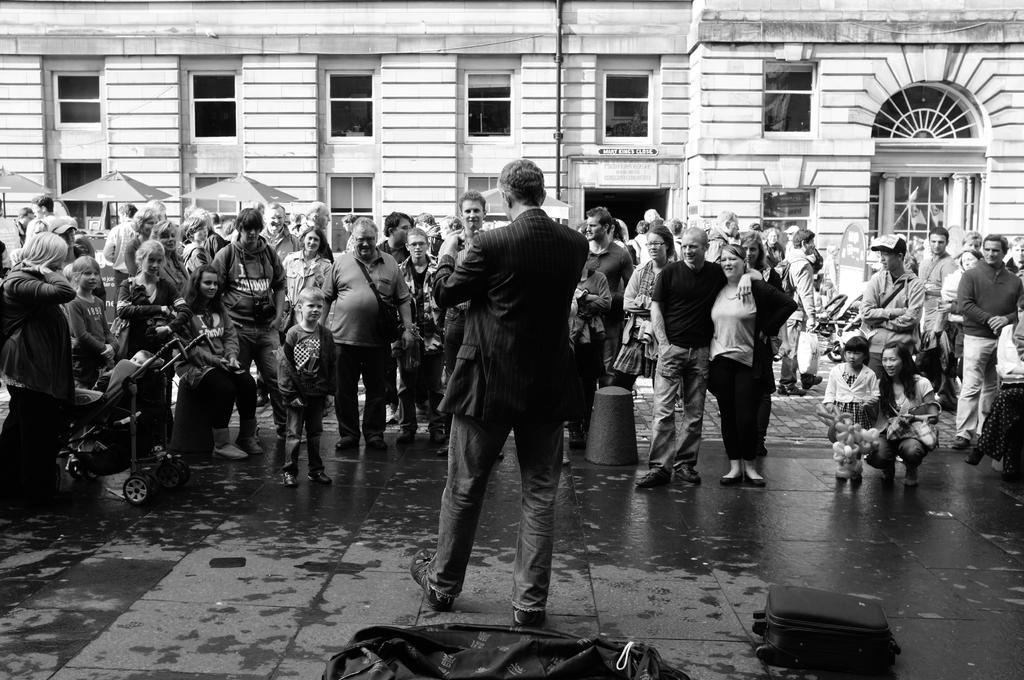What is the color scheme of the image? The image is black and white. How many people are in the image? There are many people in the image. Where are the people located in the image? The people are standing in the back. Can you describe the man in the middle of the image? There is a man standing in the middle of the image, and he is wearing a coat. What can be seen in the background of the image? There is a building in the background of the image. What type of rice is being served by the servant in the image? There is no servant or rice present in the image. How many bulbs are visible in the image? There are no bulbs visible in the image. 